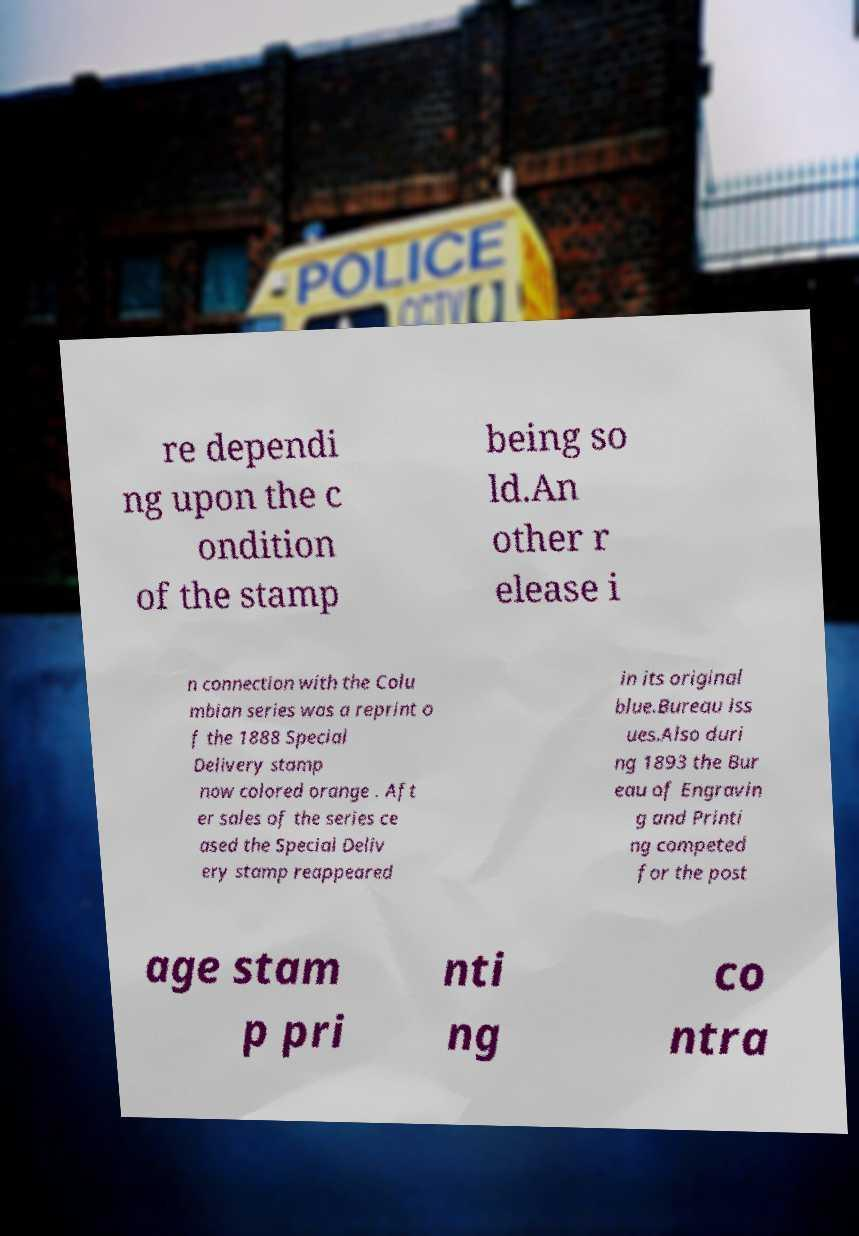Please read and relay the text visible in this image. What does it say? re dependi ng upon the c ondition of the stamp being so ld.An other r elease i n connection with the Colu mbian series was a reprint o f the 1888 Special Delivery stamp now colored orange . Aft er sales of the series ce ased the Special Deliv ery stamp reappeared in its original blue.Bureau iss ues.Also duri ng 1893 the Bur eau of Engravin g and Printi ng competed for the post age stam p pri nti ng co ntra 